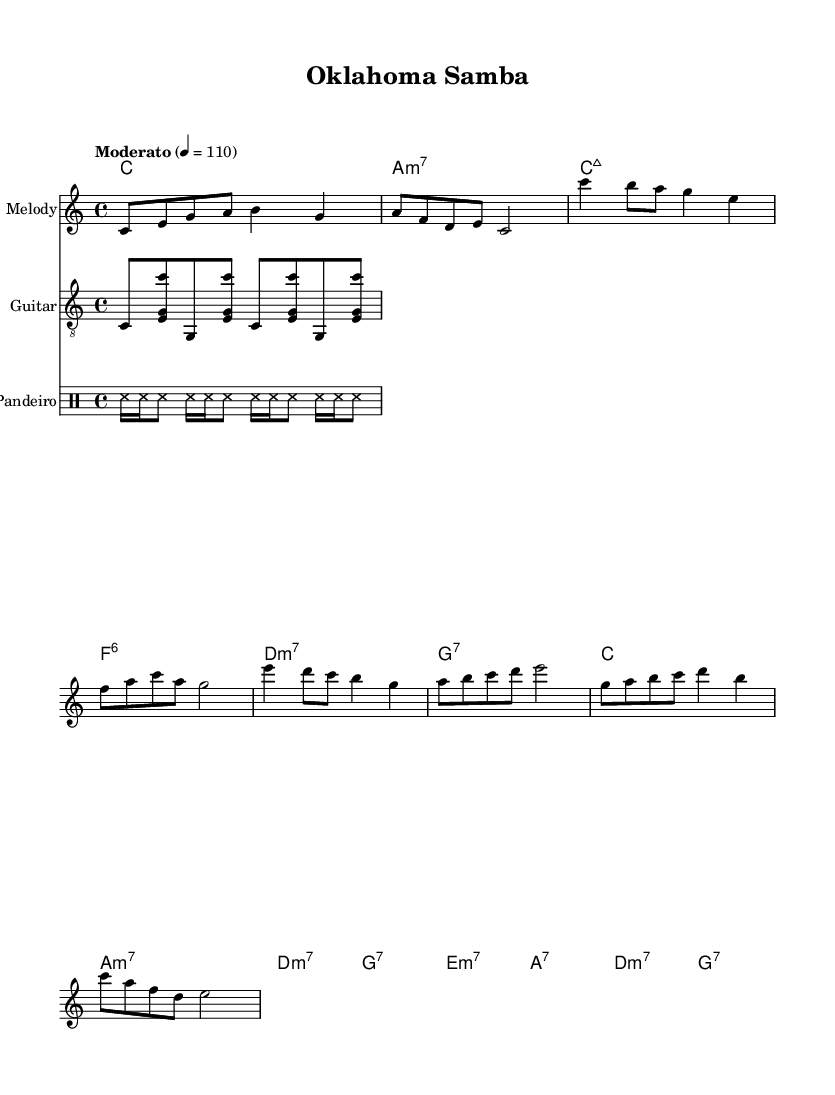what is the key signature of this music? The key signature is C major, which has no sharps or flats.
Answer: C major what is the time signature of this piece? The time signature is indicated as 4/4, which means there are four beats in each measure.
Answer: 4/4 what is the tempo marking for the piece? The tempo marking states "Moderato," which suggests a moderate speed, specifically set to a metronome marking of 110 beats per minute.
Answer: Moderato how many measures are in the Chorus section? By examining the sheet music, the Chorus section has 4 measures, which can be identified by counting the chords and the corresponding melody lines.
Answer: 4 measures what type of guitar pattern is utilized in this sheet music? The guitar pattern is based on a repetitive arpeggiation of notes, specifically a flickering style that is characteristic of Bossa Nova, evidenced by the chord placements in the guitar section.
Answer: Arpeggiated which rhythmic instrument is indicated in the score? The rhythmic instrument indicated is the Pandeiro, a type of hand-held drum commonly used in Brazilian music, as noted in the percussion section of the score.
Answer: Pandeiro how is the Bridge section characterized in terms of harmony? The Bridge section is characterized by the use of minor seventh chords and dominant seventh chords, which create a contrasting emotional feel to the previous sections.
Answer: Minor and dominant seventh chords 